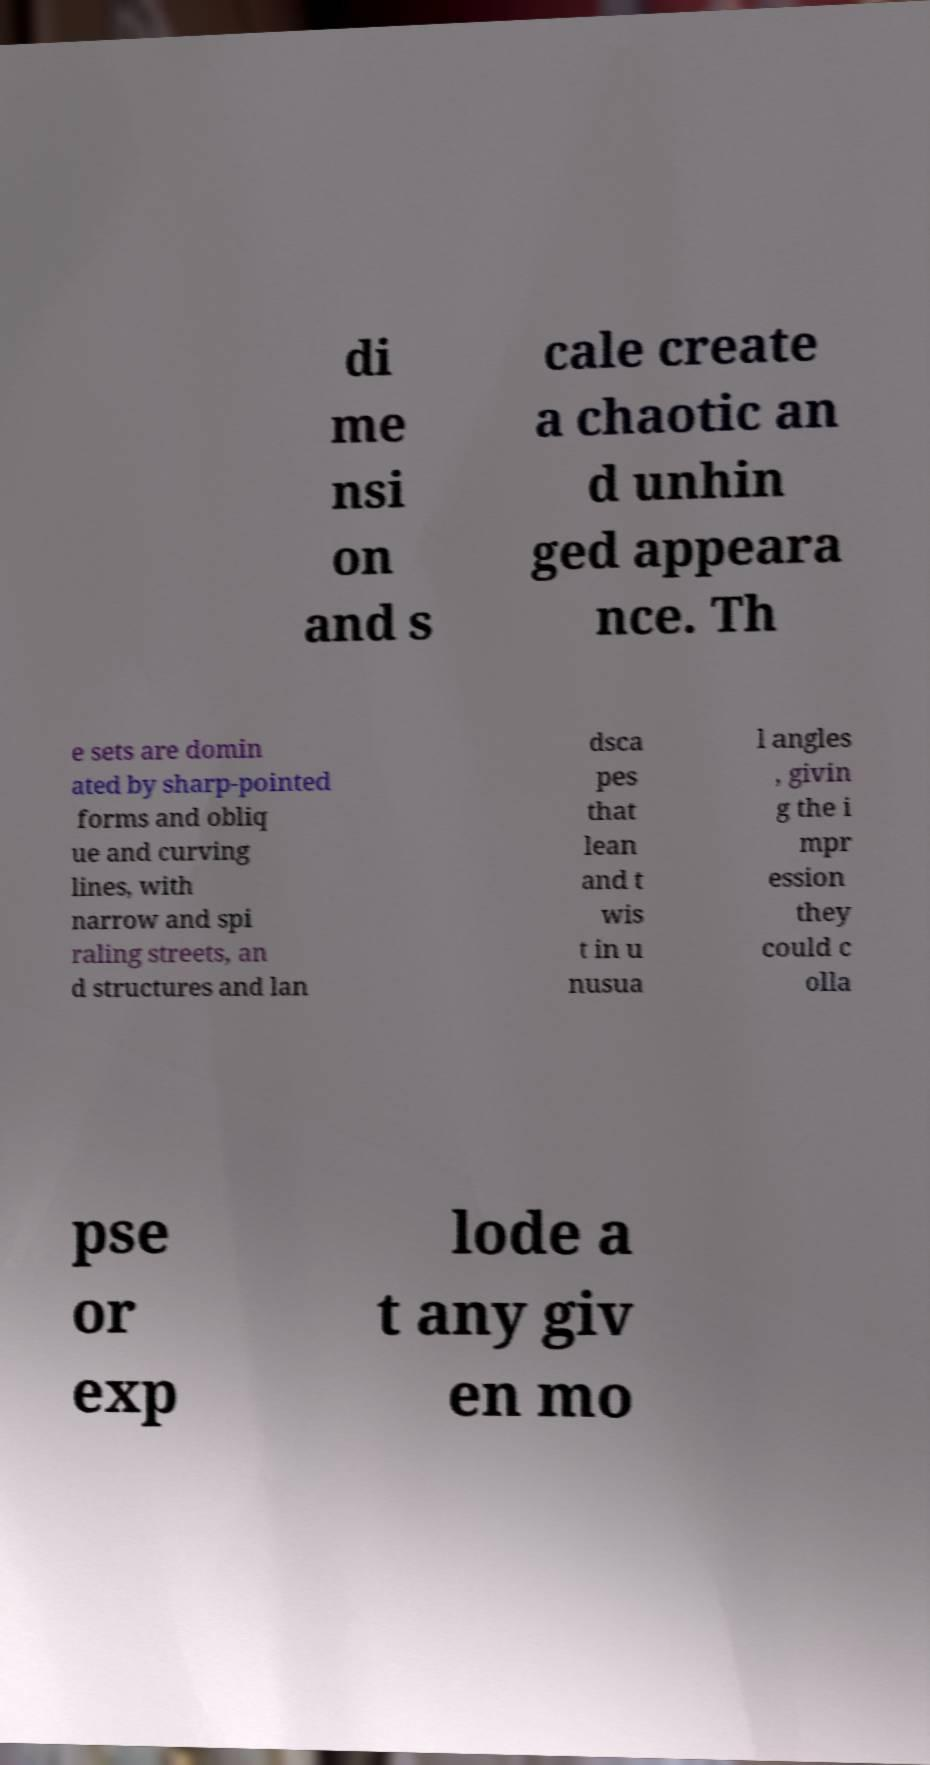Could you assist in decoding the text presented in this image and type it out clearly? di me nsi on and s cale create a chaotic an d unhin ged appeara nce. Th e sets are domin ated by sharp-pointed forms and obliq ue and curving lines, with narrow and spi raling streets, an d structures and lan dsca pes that lean and t wis t in u nusua l angles , givin g the i mpr ession they could c olla pse or exp lode a t any giv en mo 